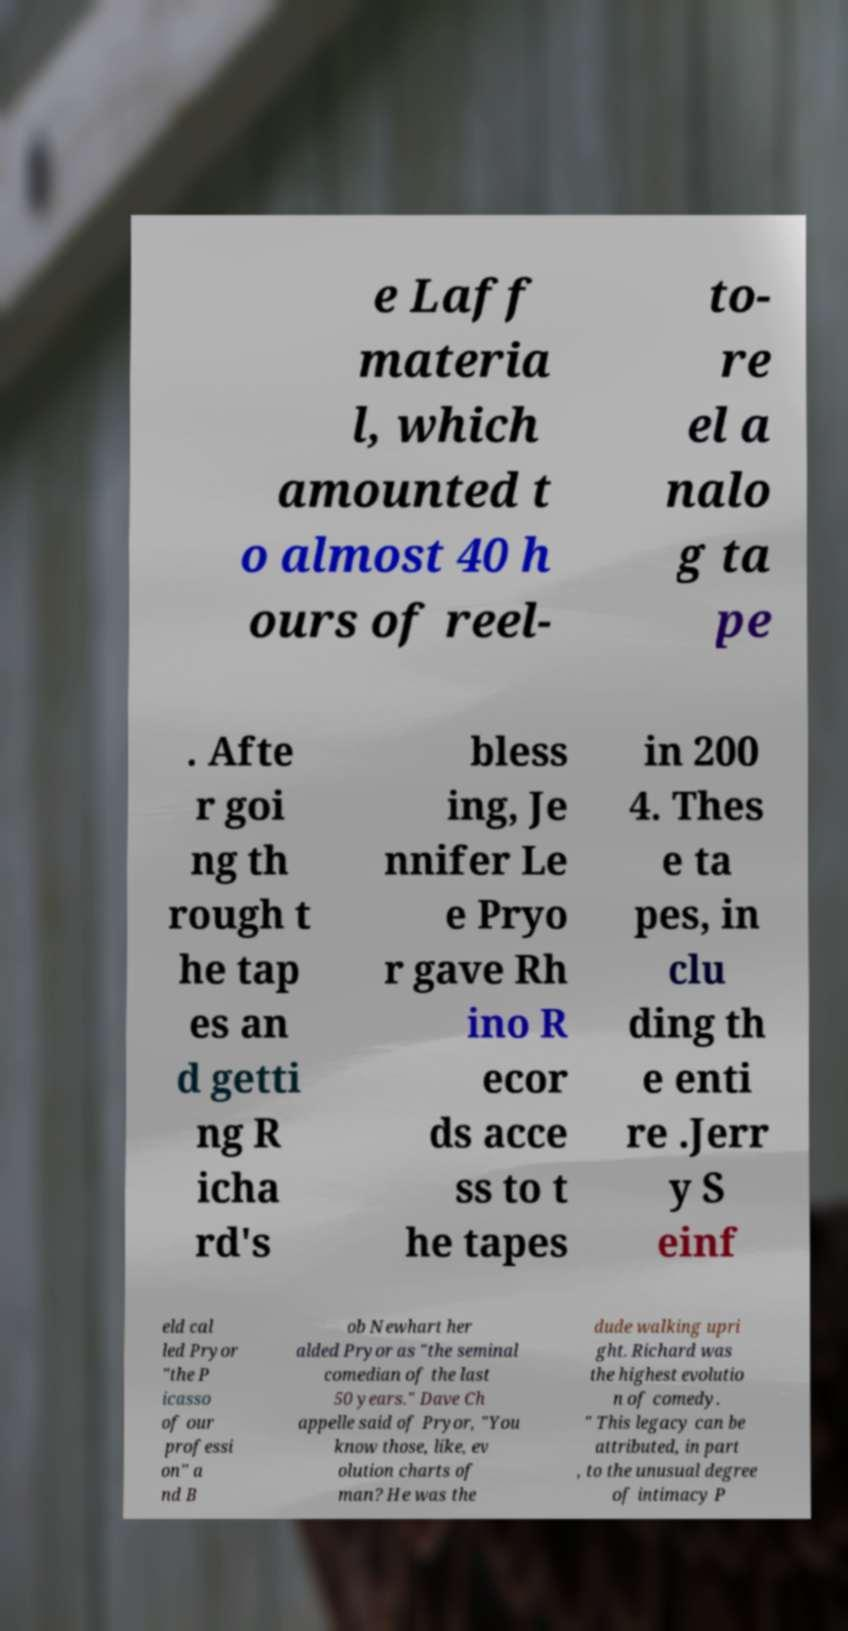Could you extract and type out the text from this image? e Laff materia l, which amounted t o almost 40 h ours of reel- to- re el a nalo g ta pe . Afte r goi ng th rough t he tap es an d getti ng R icha rd's bless ing, Je nnifer Le e Pryo r gave Rh ino R ecor ds acce ss to t he tapes in 200 4. Thes e ta pes, in clu ding th e enti re .Jerr y S einf eld cal led Pryor "the P icasso of our professi on" a nd B ob Newhart her alded Pryor as "the seminal comedian of the last 50 years." Dave Ch appelle said of Pryor, "You know those, like, ev olution charts of man? He was the dude walking upri ght. Richard was the highest evolutio n of comedy. " This legacy can be attributed, in part , to the unusual degree of intimacy P 